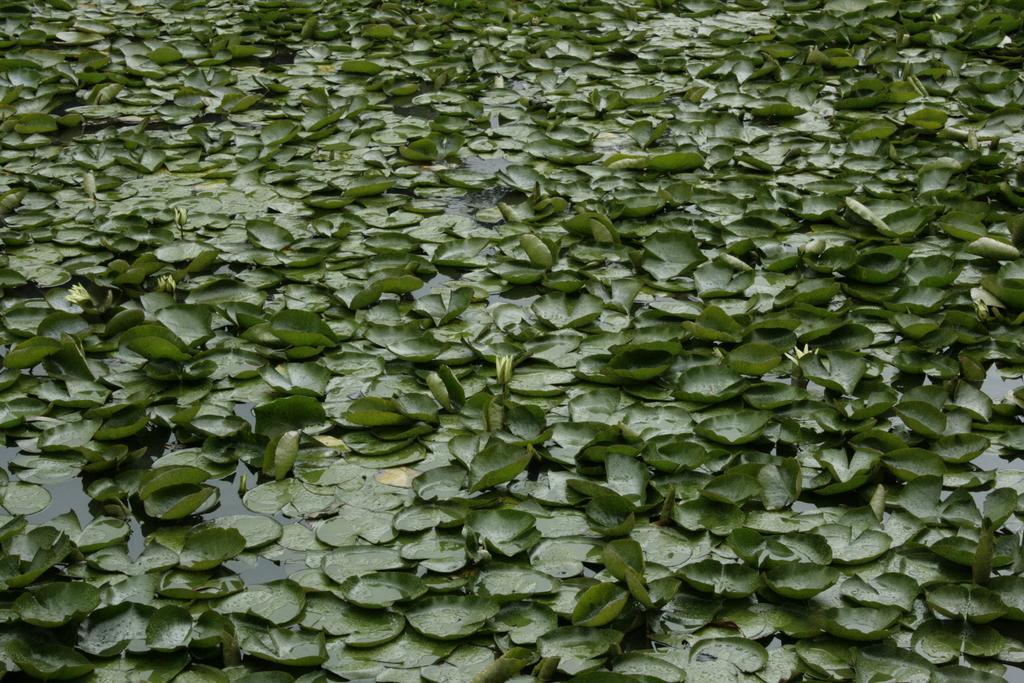Could you give a brief overview of what you see in this image? In this image I can see the green leaves on the water. 